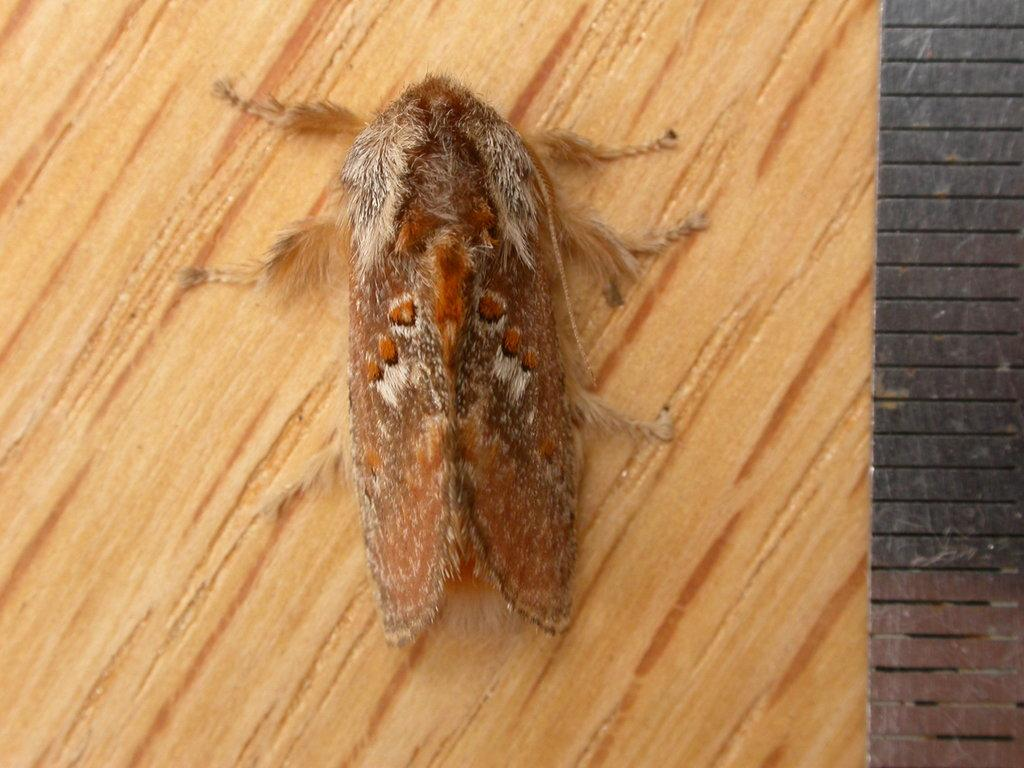What piece of furniture is present in the image? There is a table in the image. Are there any living organisms visible on the table? Yes, there is a fly on the table. What type of locket is the fly wearing on its elbow in the image? There is no locket or elbow present in the image, as it only features a table and a fly. 